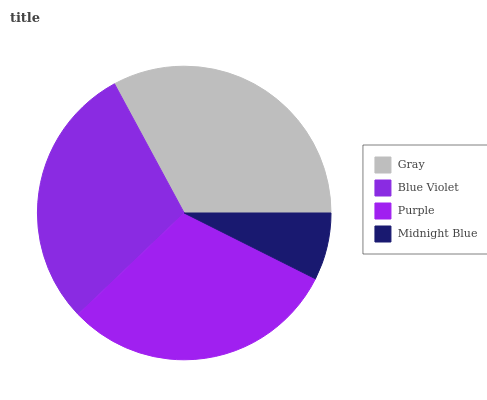Is Midnight Blue the minimum?
Answer yes or no. Yes. Is Gray the maximum?
Answer yes or no. Yes. Is Blue Violet the minimum?
Answer yes or no. No. Is Blue Violet the maximum?
Answer yes or no. No. Is Gray greater than Blue Violet?
Answer yes or no. Yes. Is Blue Violet less than Gray?
Answer yes or no. Yes. Is Blue Violet greater than Gray?
Answer yes or no. No. Is Gray less than Blue Violet?
Answer yes or no. No. Is Purple the high median?
Answer yes or no. Yes. Is Blue Violet the low median?
Answer yes or no. Yes. Is Blue Violet the high median?
Answer yes or no. No. Is Purple the low median?
Answer yes or no. No. 